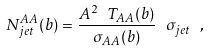<formula> <loc_0><loc_0><loc_500><loc_500>N _ { j e t } ^ { A A } ( b ) = \frac { A ^ { 2 } \ T _ { A A } ( b ) } { \sigma _ { A A } ( b ) } \ \sigma _ { j e t } \ ,</formula> 